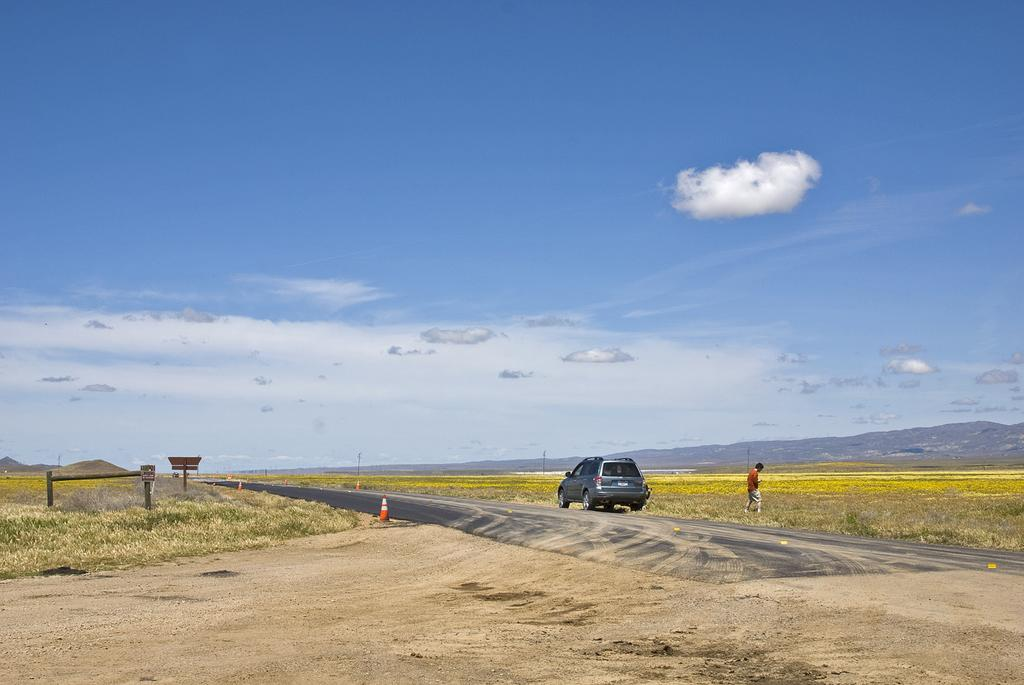What is the main feature of the image? There is a road in the image. What else can be seen on the road? There is a vehicle in the image. Are there any objects placed on the road? Traffic cones are present in the image. What type of natural environment is visible in the image? There is grass in the image, and mountains can be seen in the background. What structures are visible in the image? Poles are visible in the image. Is there any human presence in the image? Yes, there is a person standing in the image. What else can be seen in the image? There are some objects in the image. What is visible in the sky? The sky is visible in the background of the image, and clouds are present in the sky. How many cattle can be seen grazing in the image? There are no cattle present in the image. What type of ear is visible on the person in the image? The image does not show the person's ears, so it cannot be determined what type of ear is visible. 